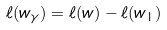Convert formula to latex. <formula><loc_0><loc_0><loc_500><loc_500>\ell ( w _ { \gamma } ) = \ell ( w ) - \ell ( w _ { 1 } )</formula> 